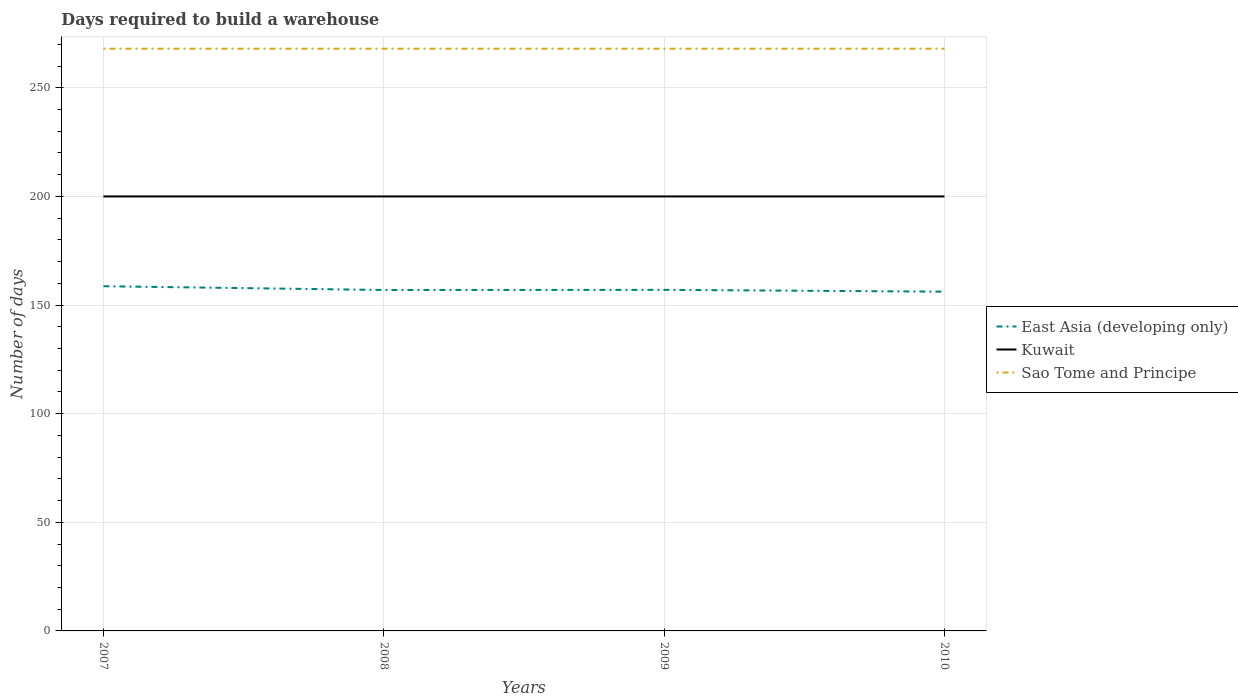How many different coloured lines are there?
Keep it short and to the point. 3. Does the line corresponding to Sao Tome and Principe intersect with the line corresponding to Kuwait?
Your answer should be compact. No. Across all years, what is the maximum days required to build a warehouse in in Kuwait?
Give a very brief answer. 200. In which year was the days required to build a warehouse in in Sao Tome and Principe maximum?
Provide a short and direct response. 2007. What is the total days required to build a warehouse in in Kuwait in the graph?
Keep it short and to the point. 0. What is the difference between the highest and the second highest days required to build a warehouse in in Kuwait?
Your answer should be compact. 0. What is the difference between the highest and the lowest days required to build a warehouse in in Sao Tome and Principe?
Provide a succinct answer. 0. Is the days required to build a warehouse in in East Asia (developing only) strictly greater than the days required to build a warehouse in in Sao Tome and Principe over the years?
Keep it short and to the point. Yes. How many lines are there?
Your answer should be compact. 3. How many years are there in the graph?
Provide a succinct answer. 4. What is the difference between two consecutive major ticks on the Y-axis?
Your answer should be compact. 50. Where does the legend appear in the graph?
Offer a terse response. Center right. How many legend labels are there?
Keep it short and to the point. 3. What is the title of the graph?
Offer a terse response. Days required to build a warehouse. Does "Mongolia" appear as one of the legend labels in the graph?
Ensure brevity in your answer.  No. What is the label or title of the X-axis?
Offer a very short reply. Years. What is the label or title of the Y-axis?
Keep it short and to the point. Number of days. What is the Number of days of East Asia (developing only) in 2007?
Your answer should be compact. 158.67. What is the Number of days of Kuwait in 2007?
Your response must be concise. 200. What is the Number of days of Sao Tome and Principe in 2007?
Ensure brevity in your answer.  268. What is the Number of days in East Asia (developing only) in 2008?
Offer a terse response. 156.94. What is the Number of days of Sao Tome and Principe in 2008?
Keep it short and to the point. 268. What is the Number of days of East Asia (developing only) in 2009?
Your answer should be very brief. 157. What is the Number of days in Sao Tome and Principe in 2009?
Your answer should be compact. 268. What is the Number of days of East Asia (developing only) in 2010?
Keep it short and to the point. 156.17. What is the Number of days of Sao Tome and Principe in 2010?
Make the answer very short. 268. Across all years, what is the maximum Number of days in East Asia (developing only)?
Provide a succinct answer. 158.67. Across all years, what is the maximum Number of days of Sao Tome and Principe?
Your response must be concise. 268. Across all years, what is the minimum Number of days in East Asia (developing only)?
Offer a terse response. 156.17. Across all years, what is the minimum Number of days of Kuwait?
Give a very brief answer. 200. Across all years, what is the minimum Number of days of Sao Tome and Principe?
Keep it short and to the point. 268. What is the total Number of days in East Asia (developing only) in the graph?
Ensure brevity in your answer.  628.78. What is the total Number of days of Kuwait in the graph?
Provide a succinct answer. 800. What is the total Number of days of Sao Tome and Principe in the graph?
Your answer should be compact. 1072. What is the difference between the Number of days of East Asia (developing only) in 2007 and that in 2008?
Offer a very short reply. 1.72. What is the difference between the Number of days in Sao Tome and Principe in 2007 and that in 2010?
Your answer should be compact. 0. What is the difference between the Number of days in East Asia (developing only) in 2008 and that in 2009?
Provide a short and direct response. -0.06. What is the difference between the Number of days of Kuwait in 2008 and that in 2010?
Your answer should be compact. 0. What is the difference between the Number of days of Kuwait in 2009 and that in 2010?
Your answer should be very brief. 0. What is the difference between the Number of days in East Asia (developing only) in 2007 and the Number of days in Kuwait in 2008?
Keep it short and to the point. -41.33. What is the difference between the Number of days in East Asia (developing only) in 2007 and the Number of days in Sao Tome and Principe in 2008?
Provide a short and direct response. -109.33. What is the difference between the Number of days of Kuwait in 2007 and the Number of days of Sao Tome and Principe in 2008?
Your answer should be compact. -68. What is the difference between the Number of days of East Asia (developing only) in 2007 and the Number of days of Kuwait in 2009?
Ensure brevity in your answer.  -41.33. What is the difference between the Number of days in East Asia (developing only) in 2007 and the Number of days in Sao Tome and Principe in 2009?
Give a very brief answer. -109.33. What is the difference between the Number of days in Kuwait in 2007 and the Number of days in Sao Tome and Principe in 2009?
Make the answer very short. -68. What is the difference between the Number of days of East Asia (developing only) in 2007 and the Number of days of Kuwait in 2010?
Offer a very short reply. -41.33. What is the difference between the Number of days in East Asia (developing only) in 2007 and the Number of days in Sao Tome and Principe in 2010?
Provide a short and direct response. -109.33. What is the difference between the Number of days in Kuwait in 2007 and the Number of days in Sao Tome and Principe in 2010?
Your answer should be compact. -68. What is the difference between the Number of days in East Asia (developing only) in 2008 and the Number of days in Kuwait in 2009?
Your response must be concise. -43.06. What is the difference between the Number of days of East Asia (developing only) in 2008 and the Number of days of Sao Tome and Principe in 2009?
Offer a terse response. -111.06. What is the difference between the Number of days in Kuwait in 2008 and the Number of days in Sao Tome and Principe in 2009?
Offer a terse response. -68. What is the difference between the Number of days of East Asia (developing only) in 2008 and the Number of days of Kuwait in 2010?
Provide a short and direct response. -43.06. What is the difference between the Number of days of East Asia (developing only) in 2008 and the Number of days of Sao Tome and Principe in 2010?
Offer a very short reply. -111.06. What is the difference between the Number of days in Kuwait in 2008 and the Number of days in Sao Tome and Principe in 2010?
Give a very brief answer. -68. What is the difference between the Number of days in East Asia (developing only) in 2009 and the Number of days in Kuwait in 2010?
Offer a very short reply. -43. What is the difference between the Number of days of East Asia (developing only) in 2009 and the Number of days of Sao Tome and Principe in 2010?
Offer a terse response. -111. What is the difference between the Number of days in Kuwait in 2009 and the Number of days in Sao Tome and Principe in 2010?
Your response must be concise. -68. What is the average Number of days in East Asia (developing only) per year?
Ensure brevity in your answer.  157.19. What is the average Number of days in Kuwait per year?
Provide a short and direct response. 200. What is the average Number of days in Sao Tome and Principe per year?
Your answer should be compact. 268. In the year 2007, what is the difference between the Number of days in East Asia (developing only) and Number of days in Kuwait?
Your response must be concise. -41.33. In the year 2007, what is the difference between the Number of days of East Asia (developing only) and Number of days of Sao Tome and Principe?
Keep it short and to the point. -109.33. In the year 2007, what is the difference between the Number of days of Kuwait and Number of days of Sao Tome and Principe?
Your answer should be very brief. -68. In the year 2008, what is the difference between the Number of days in East Asia (developing only) and Number of days in Kuwait?
Provide a short and direct response. -43.06. In the year 2008, what is the difference between the Number of days of East Asia (developing only) and Number of days of Sao Tome and Principe?
Offer a terse response. -111.06. In the year 2008, what is the difference between the Number of days of Kuwait and Number of days of Sao Tome and Principe?
Your response must be concise. -68. In the year 2009, what is the difference between the Number of days of East Asia (developing only) and Number of days of Kuwait?
Ensure brevity in your answer.  -43. In the year 2009, what is the difference between the Number of days of East Asia (developing only) and Number of days of Sao Tome and Principe?
Make the answer very short. -111. In the year 2009, what is the difference between the Number of days in Kuwait and Number of days in Sao Tome and Principe?
Make the answer very short. -68. In the year 2010, what is the difference between the Number of days of East Asia (developing only) and Number of days of Kuwait?
Give a very brief answer. -43.83. In the year 2010, what is the difference between the Number of days in East Asia (developing only) and Number of days in Sao Tome and Principe?
Your answer should be compact. -111.83. In the year 2010, what is the difference between the Number of days of Kuwait and Number of days of Sao Tome and Principe?
Give a very brief answer. -68. What is the ratio of the Number of days in East Asia (developing only) in 2007 to that in 2008?
Give a very brief answer. 1.01. What is the ratio of the Number of days of Kuwait in 2007 to that in 2008?
Give a very brief answer. 1. What is the ratio of the Number of days of Sao Tome and Principe in 2007 to that in 2008?
Your answer should be compact. 1. What is the ratio of the Number of days of East Asia (developing only) in 2007 to that in 2009?
Your answer should be compact. 1.01. What is the ratio of the Number of days in Kuwait in 2007 to that in 2009?
Your response must be concise. 1. What is the ratio of the Number of days in East Asia (developing only) in 2007 to that in 2010?
Ensure brevity in your answer.  1.02. What is the ratio of the Number of days of Sao Tome and Principe in 2007 to that in 2010?
Your answer should be very brief. 1. What is the ratio of the Number of days of Sao Tome and Principe in 2008 to that in 2009?
Offer a very short reply. 1. What is the ratio of the Number of days of East Asia (developing only) in 2008 to that in 2010?
Keep it short and to the point. 1. What is the ratio of the Number of days in Kuwait in 2008 to that in 2010?
Keep it short and to the point. 1. What is the ratio of the Number of days in East Asia (developing only) in 2009 to that in 2010?
Your answer should be very brief. 1.01. What is the ratio of the Number of days of Kuwait in 2009 to that in 2010?
Your response must be concise. 1. What is the difference between the highest and the second highest Number of days of East Asia (developing only)?
Provide a short and direct response. 1.67. What is the difference between the highest and the second highest Number of days of Kuwait?
Keep it short and to the point. 0. What is the difference between the highest and the lowest Number of days of East Asia (developing only)?
Give a very brief answer. 2.5. What is the difference between the highest and the lowest Number of days of Kuwait?
Give a very brief answer. 0. What is the difference between the highest and the lowest Number of days in Sao Tome and Principe?
Give a very brief answer. 0. 